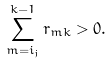Convert formula to latex. <formula><loc_0><loc_0><loc_500><loc_500>\sum _ { m = i _ { j } } ^ { k - 1 } r _ { m k } > 0 .</formula> 